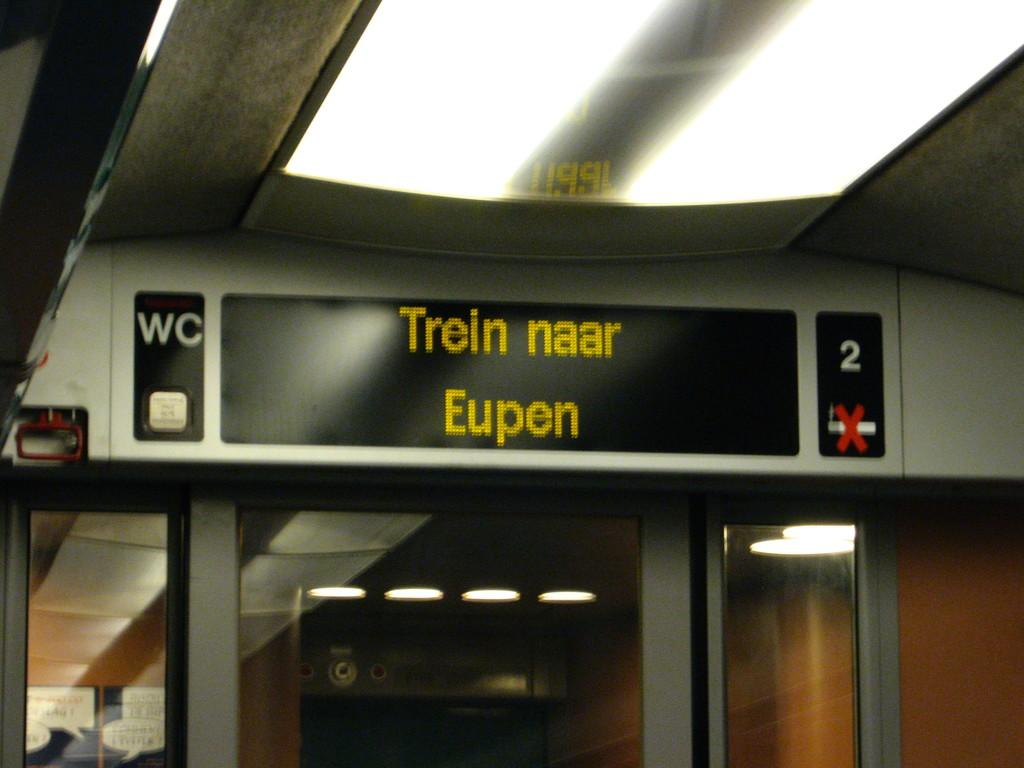What objects in the image emit light? There are lights in the image. What type of objects are present in the image that can have words written on them? There are boards in the image, and words are written on them. What is the structure at the bottom of the image that resembles a wall made of glass? There is a glass wall-like structure at the bottom of the image. What type of hall can be seen in the image? There is no hall present in the image. What language are the words written on the boards in the image? The language of the words on the boards cannot be determined from the image alone. 